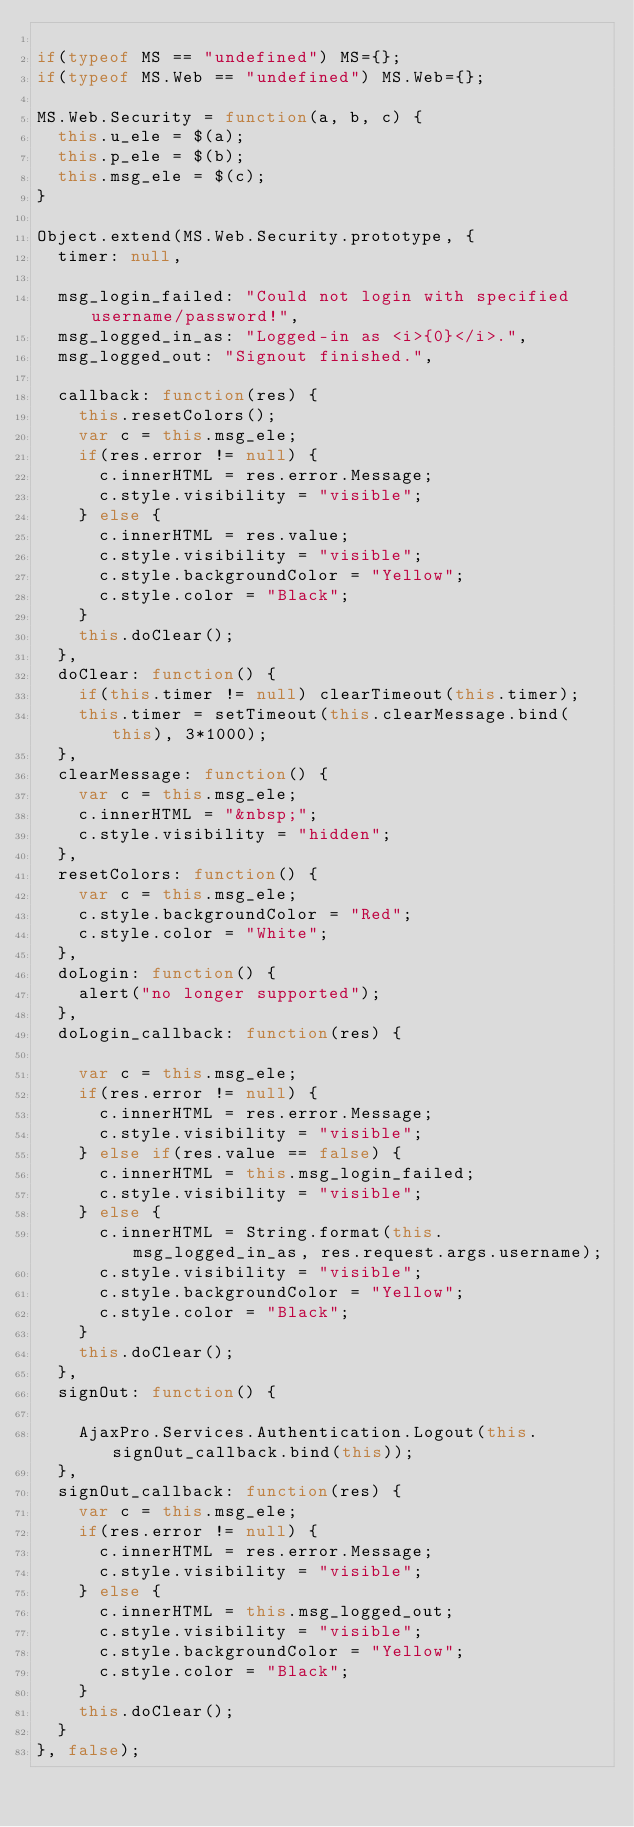<code> <loc_0><loc_0><loc_500><loc_500><_JavaScript_>
if(typeof MS == "undefined") MS={};
if(typeof MS.Web == "undefined") MS.Web={};

MS.Web.Security = function(a, b, c) {
	this.u_ele = $(a);
	this.p_ele = $(b);
	this.msg_ele = $(c);
}

Object.extend(MS.Web.Security.prototype, {
	timer: null,
	
	msg_login_failed: "Could not login with specified username/password!",
	msg_logged_in_as: "Logged-in as <i>{0}</i>.",
	msg_logged_out: "Signout finished.",
	
	callback: function(res) {
		this.resetColors();
		var c = this.msg_ele;
		if(res.error != null) {
			c.innerHTML = res.error.Message;
			c.style.visibility = "visible";
		} else {
			c.innerHTML = res.value;
			c.style.visibility = "visible";
			c.style.backgroundColor = "Yellow";
			c.style.color = "Black";
		}
		this.doClear();
	},
	doClear: function() {
		if(this.timer != null) clearTimeout(this.timer);
		this.timer = setTimeout(this.clearMessage.bind(this), 3*1000);
	},
	clearMessage: function() {
		var c = this.msg_ele;
		c.innerHTML = "&nbsp;";
		c.style.visibility = "hidden";
	},
	resetColors: function() {
		var c = this.msg_ele;
		c.style.backgroundColor = "Red";
		c.style.color = "White";
	},
	doLogin: function() {
		alert("no longer supported");
	},
	doLogin_callback: function(res) {

		var c = this.msg_ele;
		if(res.error != null) {
			c.innerHTML = res.error.Message;
			c.style.visibility = "visible";
		} else if(res.value == false) {
			c.innerHTML = this.msg_login_failed;
			c.style.visibility = "visible";
		} else {
			c.innerHTML = String.format(this.msg_logged_in_as, res.request.args.username);
			c.style.visibility = "visible";
			c.style.backgroundColor = "Yellow";
			c.style.color = "Black";
		}
		this.doClear();
	},
	signOut: function() {

		AjaxPro.Services.Authentication.Logout(this.signOut_callback.bind(this));
	},
	signOut_callback: function(res) {
		var c = this.msg_ele;
		if(res.error != null) {
			c.innerHTML = res.error.Message;
			c.style.visibility = "visible";
		} else {
			c.innerHTML = this.msg_logged_out;
			c.style.visibility = "visible";
			c.style.backgroundColor = "Yellow";
			c.style.color = "Black";
		}
		this.doClear();
	}
}, false);
</code> 